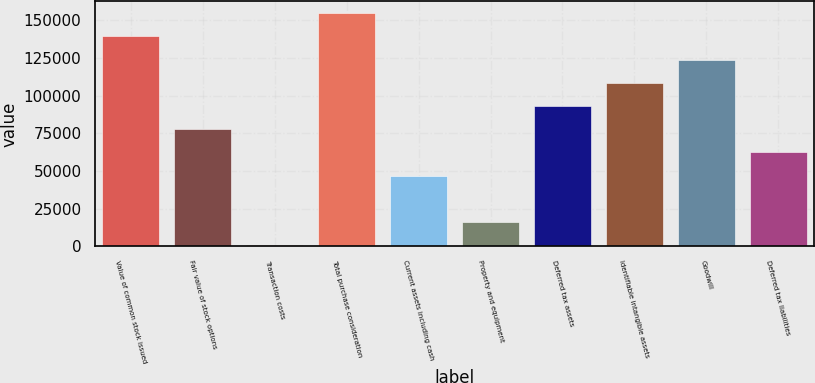Convert chart to OTSL. <chart><loc_0><loc_0><loc_500><loc_500><bar_chart><fcel>Value of common stock issued<fcel>Fair value of stock options<fcel>Transaction costs<fcel>Total purchase consideration<fcel>Current assets including cash<fcel>Property and equipment<fcel>Deferred tax assets<fcel>Identifiable intangible assets<fcel>Goodwill<fcel>Deferred tax liabilities<nl><fcel>139387<fcel>77599<fcel>847<fcel>154737<fcel>46898.2<fcel>16197.4<fcel>92949.4<fcel>108300<fcel>123650<fcel>62248.6<nl></chart> 